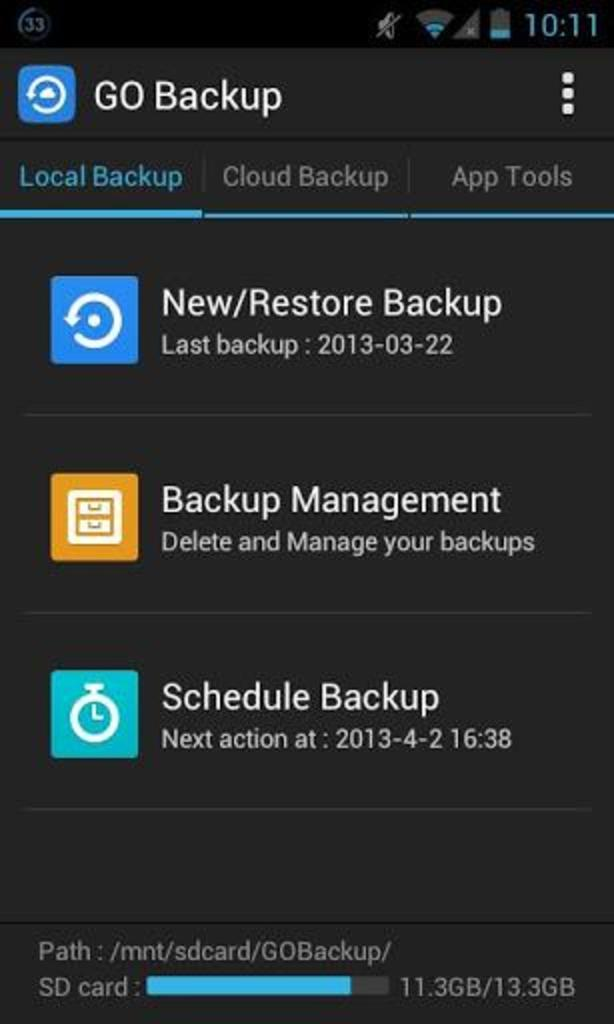<image>
Summarize the visual content of the image. the page of a phone that says new/restore backup 